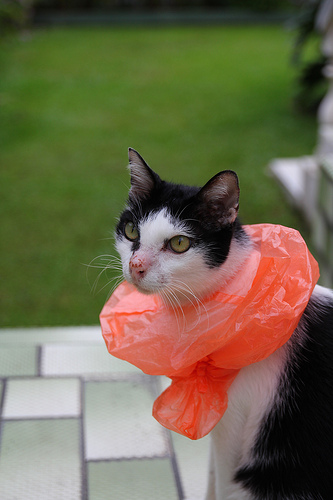<image>
Is there a bag on the cat? Yes. Looking at the image, I can see the bag is positioned on top of the cat, with the cat providing support. Is there a tile behind the plastic bag? Yes. From this viewpoint, the tile is positioned behind the plastic bag, with the plastic bag partially or fully occluding the tile. Is there a cat behind the plastic bag? No. The cat is not behind the plastic bag. From this viewpoint, the cat appears to be positioned elsewhere in the scene. 